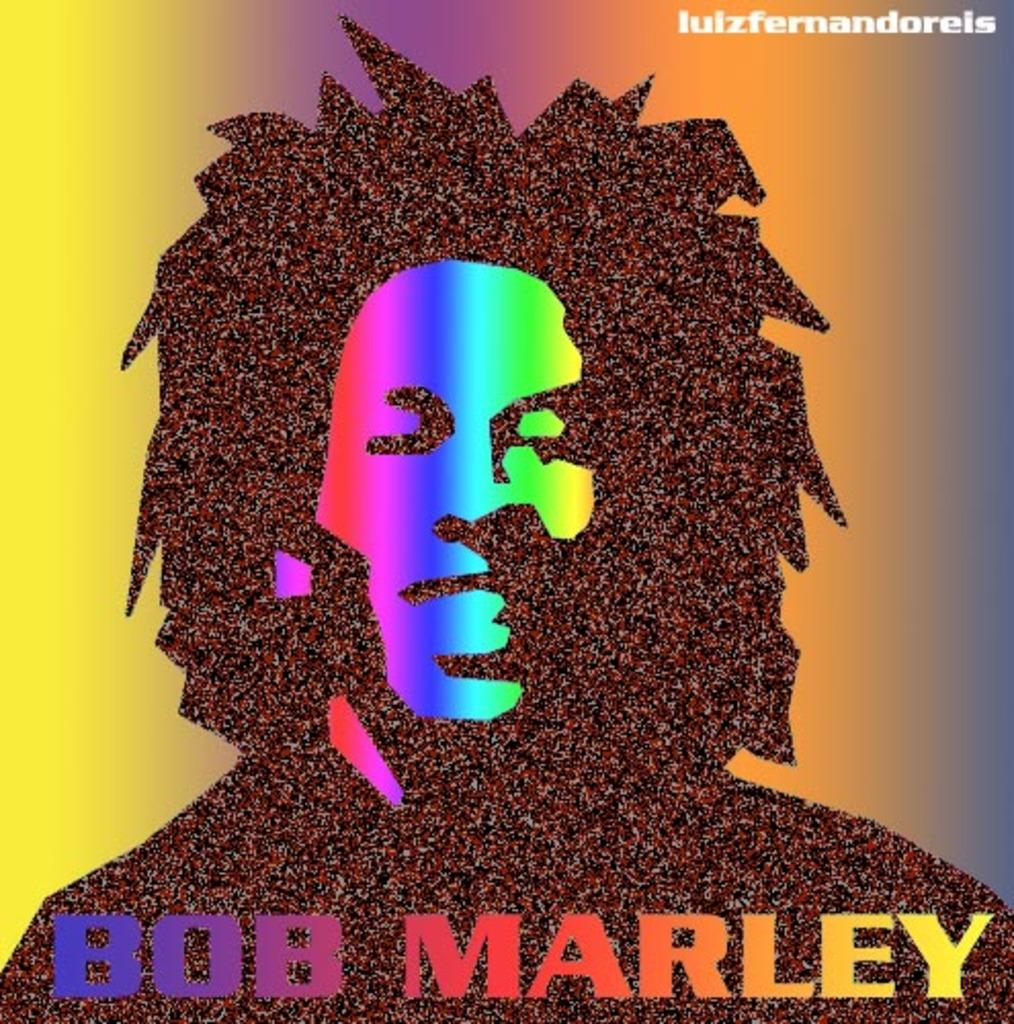<image>
Present a compact description of the photo's key features. bob marley poster or cd cover looks very colorful 